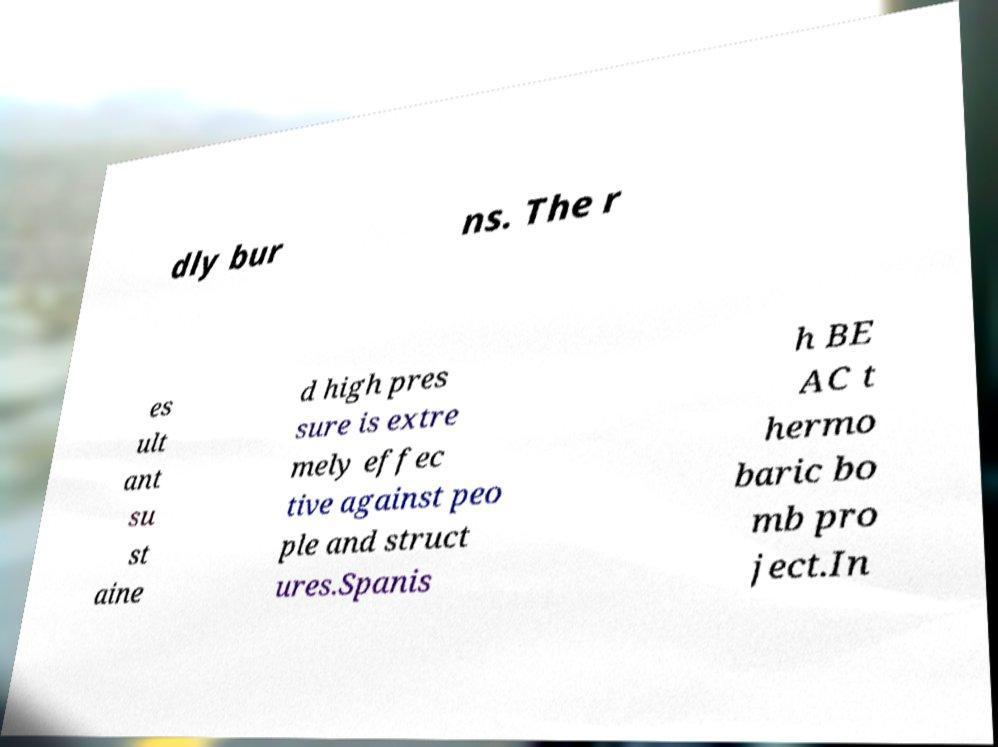Can you accurately transcribe the text from the provided image for me? dly bur ns. The r es ult ant su st aine d high pres sure is extre mely effec tive against peo ple and struct ures.Spanis h BE AC t hermo baric bo mb pro ject.In 